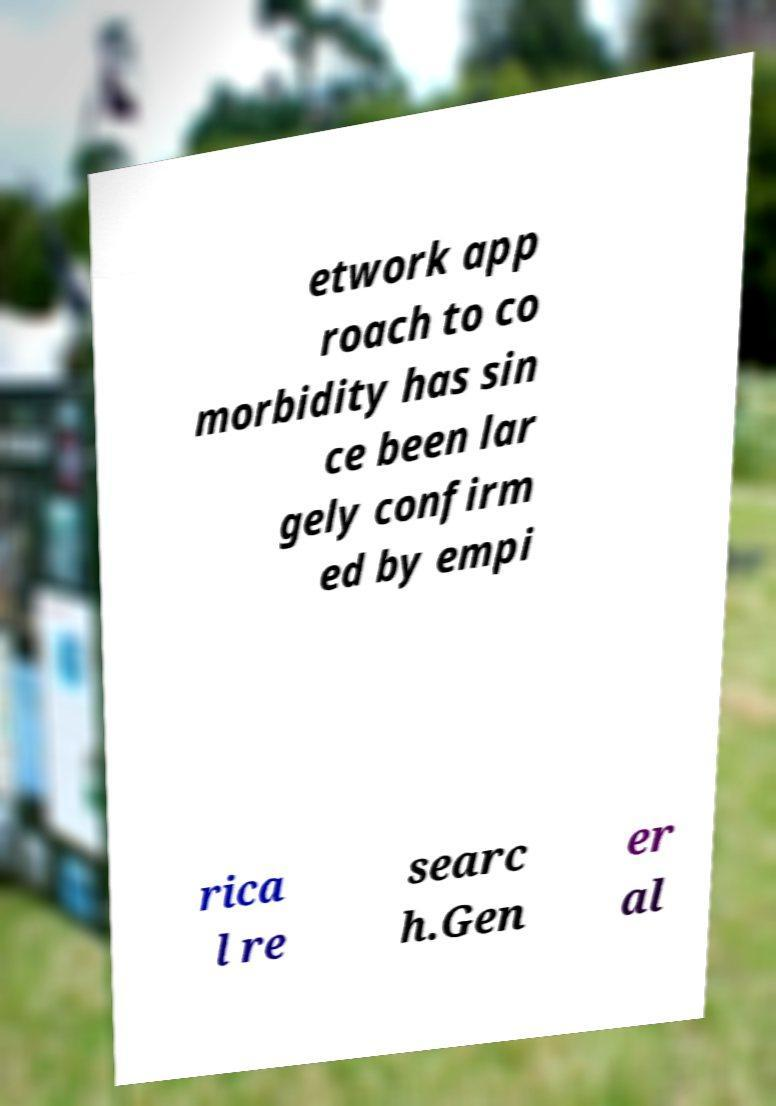Please read and relay the text visible in this image. What does it say? etwork app roach to co morbidity has sin ce been lar gely confirm ed by empi rica l re searc h.Gen er al 